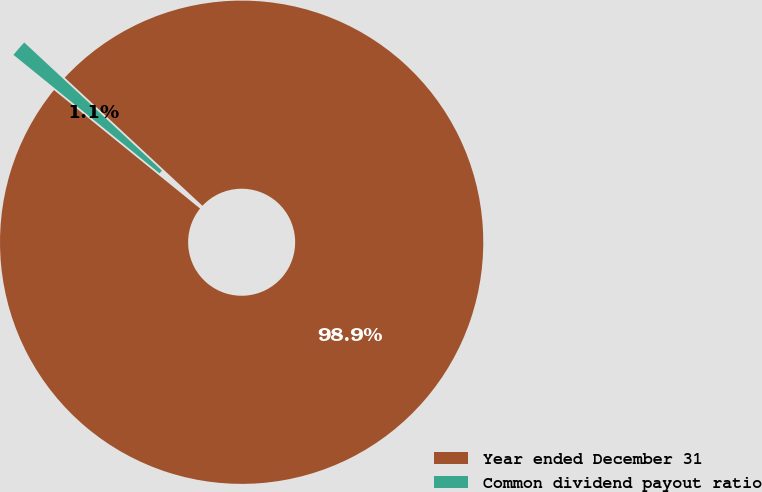<chart> <loc_0><loc_0><loc_500><loc_500><pie_chart><fcel>Year ended December 31<fcel>Common dividend payout ratio<nl><fcel>98.92%<fcel>1.08%<nl></chart> 